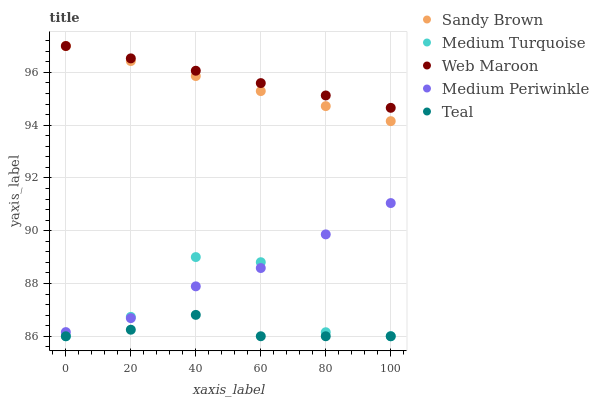Does Teal have the minimum area under the curve?
Answer yes or no. Yes. Does Web Maroon have the maximum area under the curve?
Answer yes or no. Yes. Does Sandy Brown have the minimum area under the curve?
Answer yes or no. No. Does Sandy Brown have the maximum area under the curve?
Answer yes or no. No. Is Web Maroon the smoothest?
Answer yes or no. Yes. Is Medium Turquoise the roughest?
Answer yes or no. Yes. Is Teal the smoothest?
Answer yes or no. No. Is Teal the roughest?
Answer yes or no. No. Does Teal have the lowest value?
Answer yes or no. Yes. Does Sandy Brown have the lowest value?
Answer yes or no. No. Does Sandy Brown have the highest value?
Answer yes or no. Yes. Does Teal have the highest value?
Answer yes or no. No. Is Teal less than Sandy Brown?
Answer yes or no. Yes. Is Sandy Brown greater than Medium Turquoise?
Answer yes or no. Yes. Does Web Maroon intersect Sandy Brown?
Answer yes or no. Yes. Is Web Maroon less than Sandy Brown?
Answer yes or no. No. Is Web Maroon greater than Sandy Brown?
Answer yes or no. No. Does Teal intersect Sandy Brown?
Answer yes or no. No. 